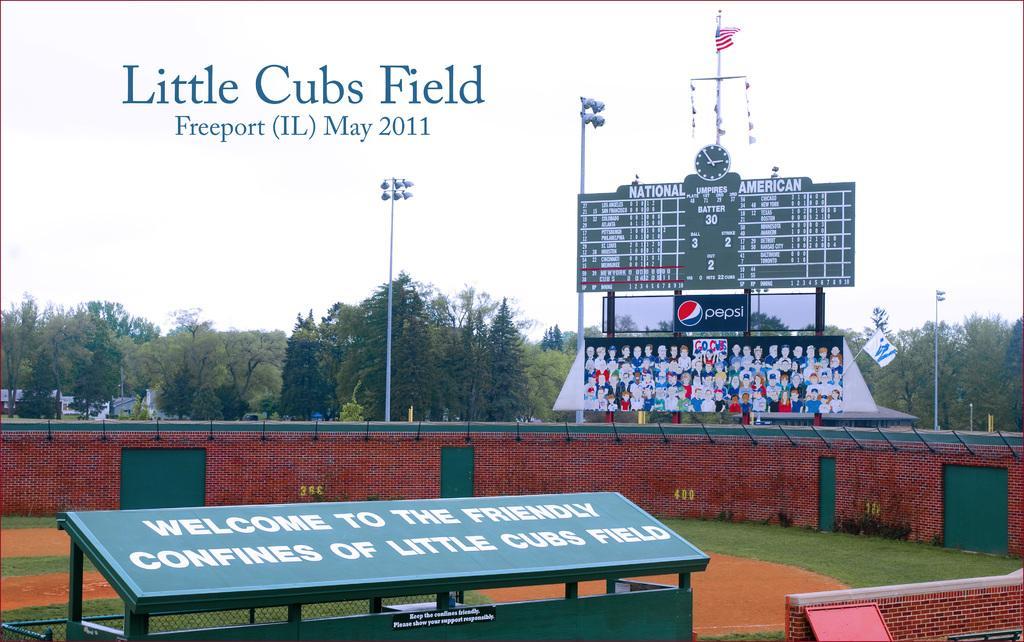Please provide a concise description of this image. In this image I can see few boards, red colour wall, few poles, number of lights, a flag, a clock, number of trees and I can also see something is written at few places. 